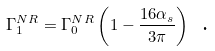<formula> <loc_0><loc_0><loc_500><loc_500>\Gamma _ { 1 } ^ { N R } = \Gamma _ { 0 } ^ { N R } \left ( 1 - \frac { 1 6 \alpha _ { s } } { 3 \pi } \right ) \text { .}</formula> 